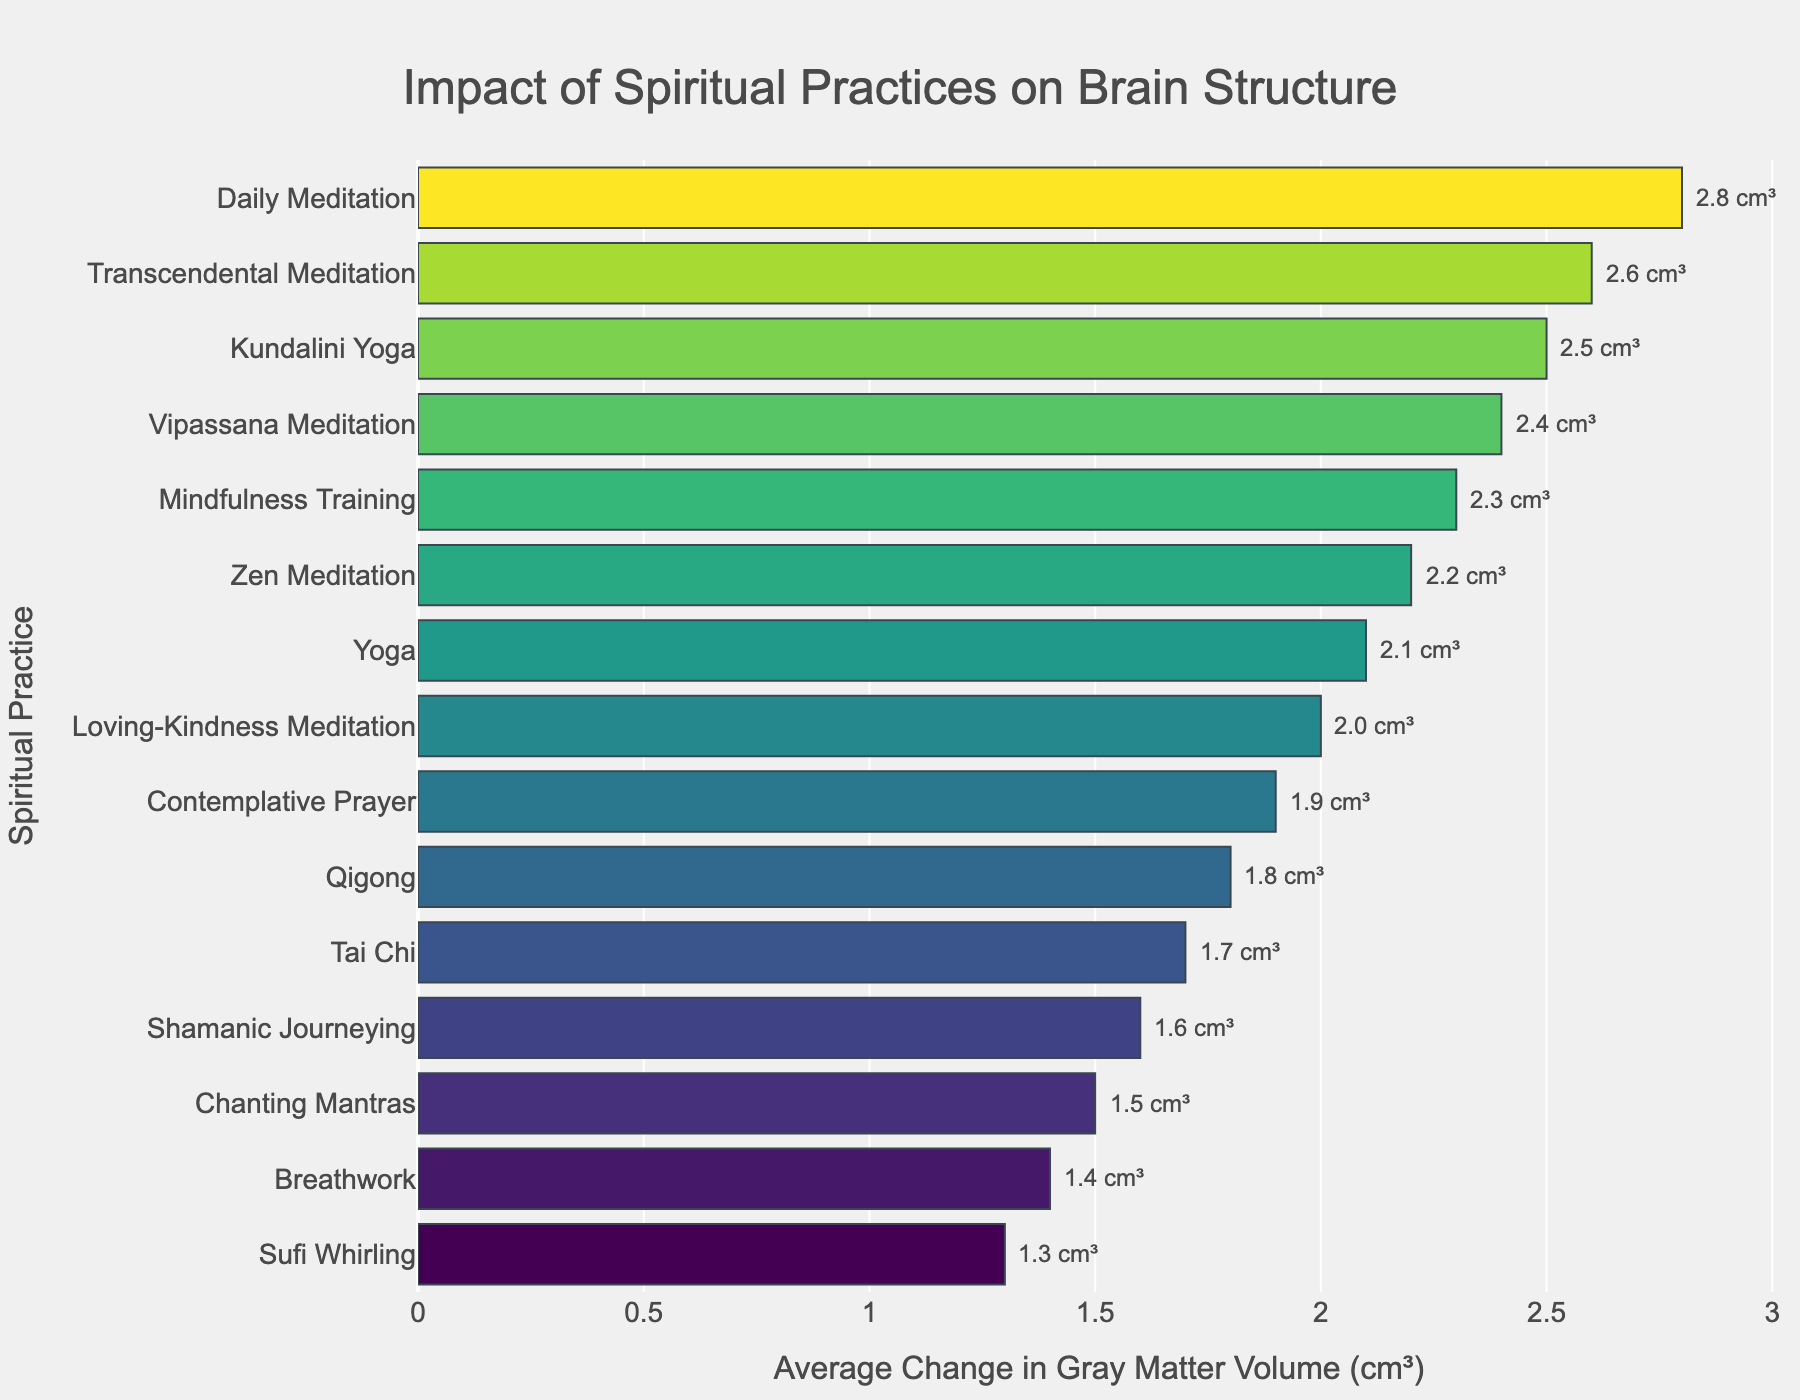Which spiritual practice has the highest average change in gray matter volume? By observing the bar chart, we can identify that "Daily Meditation" has the highest bar, corresponding to an average change of 2.8 cm³ in gray matter volume.
Answer: Daily Meditation Which practice shows a greater average increase in gray matter volume: Tai Chi or Qigong? Examining the bars for both practices, Tai Chi has a value of 1.7 cm³, while Qigong has a slightly higher value of 1.8 cm³.
Answer: Qigong What is the average change in gray matter volume for Zen Meditation and Transcendental Meditation combined? Zen Meditation has a change of 2.2 cm³ and Transcendental Meditation has 2.6 cm³. Adding them together and dividing by 2, we get (2.2 + 2.6)/2 = 2.4 cm³.
Answer: 2.4 cm³ Which practices show an average change in gray matter volume that is less than 1.5 cm³? The bar chart displays "Sufi Whirling" and "Breathwork" with average changes of 1.3 cm³ and 1.4 cm³ respectively, both of which are less than 1.5 cm³.
Answer: Sufi Whirling; Breathwork What is the total change in gray matter volume for all practices? Adding all the values from the chart: 2.8 + 1.5 + 2.3 + 1.9 + 2.1 + 1.7 + 2.6 + 2.4 + 2.0 + 2.2 + 1.3 + 1.8 + 2.5 + 1.6 + 1.4 = 31.1 cm³.
Answer: 31.1 cm³ Which practice has the smallest average change in gray matter volume and what is that value? The smallest bar on the chart corresponds to "Sufi Whirling" with an average change of 1.3 cm³.
Answer: Sufi Whirling; 1.3 cm³ Compare the changes in gray matter volumes of Kundalini Yoga and Mindfulness Training. Which one has a higher value and by how much? Kundalini Yoga has a change of 2.5 cm³, and Mindfulness Training has 2.3 cm³. The difference is 2.5 - 2.3 = 0.2 cm³.
Answer: Kundalini Yoga; 0.2 cm³ What is the median value of the average changes in gray matter volume across all the practices? To find the median, we need to order the values and find the middle one:
1.3, 1.4, 1.5, 1.6, 1.7, 1.8, 1.9, 2.0, 2.1, 2.2, 2.3, 2.4, 2.5, 2.6, 2.8. The median value, being the middle value of this ordered list, is 2.0 cm³.
Answer: 2.0 cm³ 